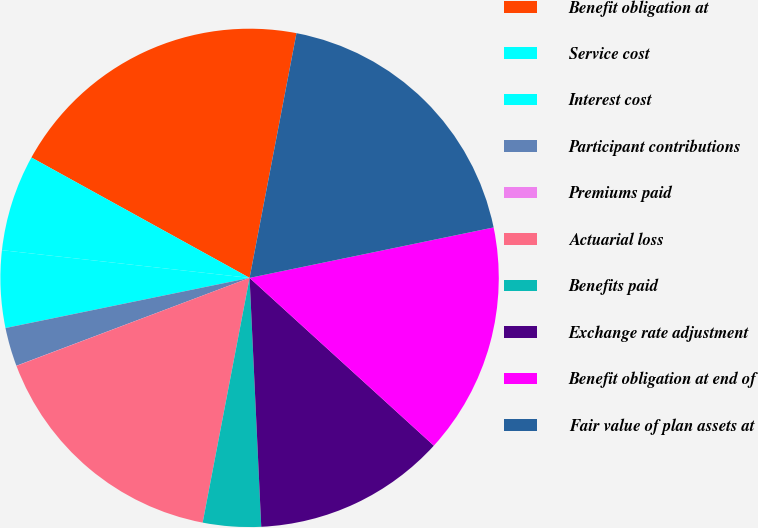Convert chart to OTSL. <chart><loc_0><loc_0><loc_500><loc_500><pie_chart><fcel>Benefit obligation at<fcel>Service cost<fcel>Interest cost<fcel>Participant contributions<fcel>Premiums paid<fcel>Actuarial loss<fcel>Benefits paid<fcel>Exchange rate adjustment<fcel>Benefit obligation at end of<fcel>Fair value of plan assets at<nl><fcel>19.99%<fcel>6.25%<fcel>5.0%<fcel>2.51%<fcel>0.01%<fcel>16.24%<fcel>3.76%<fcel>12.5%<fcel>15.0%<fcel>18.74%<nl></chart> 